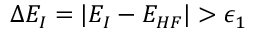<formula> <loc_0><loc_0><loc_500><loc_500>\Delta E _ { I } = | E _ { I } - E _ { H F } | > \epsilon _ { 1 }</formula> 